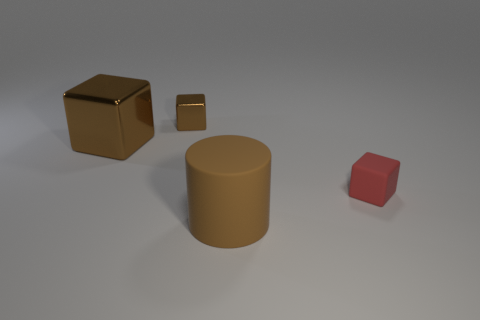There is a large rubber cylinder; are there any large brown matte objects right of it?
Provide a short and direct response. No. Is the size of the matte object to the right of the big brown rubber cylinder the same as the metallic object that is left of the tiny brown shiny cube?
Offer a terse response. No. Is there a red matte cylinder that has the same size as the rubber cube?
Offer a very short reply. No. There is a small thing that is on the left side of the tiny red matte thing; does it have the same shape as the big shiny thing?
Provide a short and direct response. Yes. What is the block that is right of the large brown cylinder made of?
Offer a very short reply. Rubber. The big object that is left of the matte object in front of the small matte block is what shape?
Make the answer very short. Cube. Does the large brown rubber thing have the same shape as the large object that is behind the matte block?
Provide a short and direct response. No. There is a small cube in front of the large metal thing; what number of tiny red objects are behind it?
Provide a short and direct response. 0. What material is the other brown thing that is the same shape as the large brown shiny object?
Your response must be concise. Metal. What number of yellow objects are cubes or tiny cubes?
Your response must be concise. 0. 